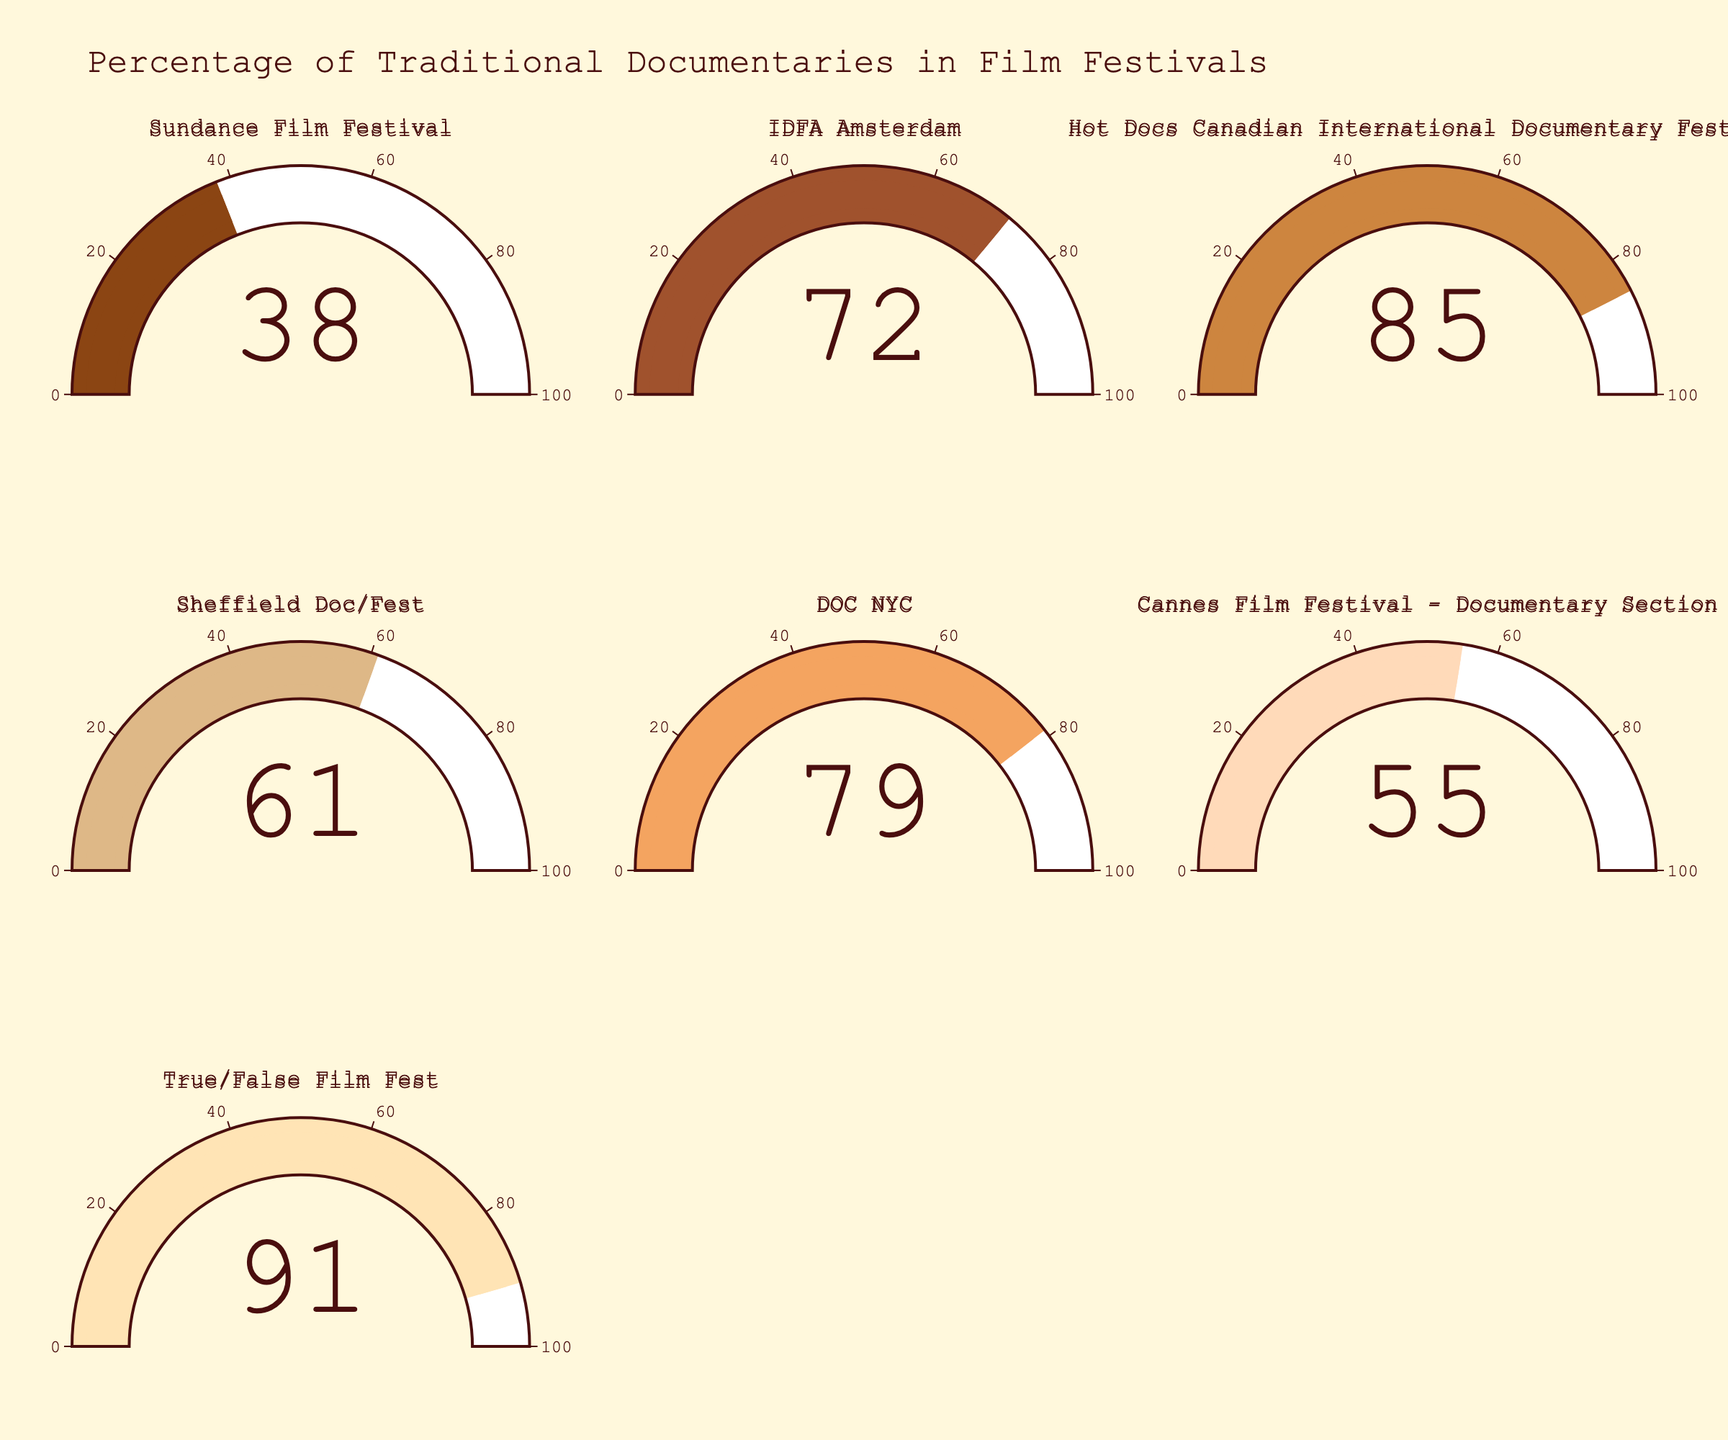What is the percentage of traditional documentaries at the IDFA Amsterdam? Refer to the IDFA Amsterdam gauge and read the percentage displayed.
Answer: 72% What is the title of this figure? Look at the top of the figure where the title is displayed.
Answer: Percentage of Traditional Documentaries in Film Festivals Which film festival has the highest percentage of traditional documentaries? Compare the values displayed on all the gauges and identify the highest one.
Answer: True/False Film Fest How many film festivals have over 70% traditional documentaries? Count the gauges with values over 70%.
Answer: 4 Which festival has the lowest percentage of traditional documentaries? Compare the values displayed on all the gauges and identify the lowest one.
Answer: Sundance Film Festival Is the percentage of traditional documentaries at DOC NYC higher or lower than at Sheffield Doc/Fest? Compare the value on DOC NYC gauge with Sheffield Doc/Fest gauge.
Answer: Higher Which festival has a percentage of traditional documentaries closest to the median value among all the festivals listed? First, list the percentages: 38, 72, 85, 61, 79, 55, 91. Arrange them in ascending order: 38, 55, 61, 72, 79, 85, 91. The median value is 72, which belongs to IDFA Amsterdam.
Answer: IDFA Amsterdam What is the average percentage of traditional documentaries across all listed film festivals? Sum the values and divide by the number of festivals: (38 + 72 + 85 + 61 + 79 + 55 + 91) / 7 = 67.2857, rounded to 67.3%.
Answer: 67.3% How much higher is the percentage of traditional documentaries at True/False Film Fest than at the Cannes Film Festival - Documentary Section? Subtract the percentage of Cannes Film Festival from that of True/False Film Fest: 91 - 55 = 36.
Answer: 36 Are there more film festivals with a percentage above or below 60% traditional documentaries? Count how many festivals are above and below 60%. Above: 5 (IDFA Amsterdam, Hot Docs, Sheffield Doc/Fest, DOC NYC, True/False Film Fest). Below: 2 (Sundance, Cannes).
Answer: Above 